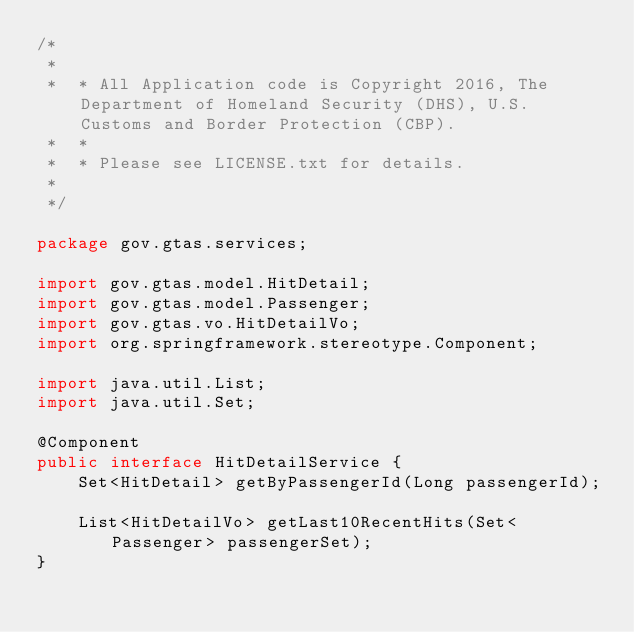<code> <loc_0><loc_0><loc_500><loc_500><_Java_>/*
 *
 *  * All Application code is Copyright 2016, The Department of Homeland Security (DHS), U.S. Customs and Border Protection (CBP).
 *  *
 *  * Please see LICENSE.txt for details.
 *
 */

package gov.gtas.services;

import gov.gtas.model.HitDetail;
import gov.gtas.model.Passenger;
import gov.gtas.vo.HitDetailVo;
import org.springframework.stereotype.Component;

import java.util.List;
import java.util.Set;

@Component
public interface HitDetailService {
	Set<HitDetail> getByPassengerId(Long passengerId);

	List<HitDetailVo> getLast10RecentHits(Set<Passenger> passengerSet);
}
</code> 